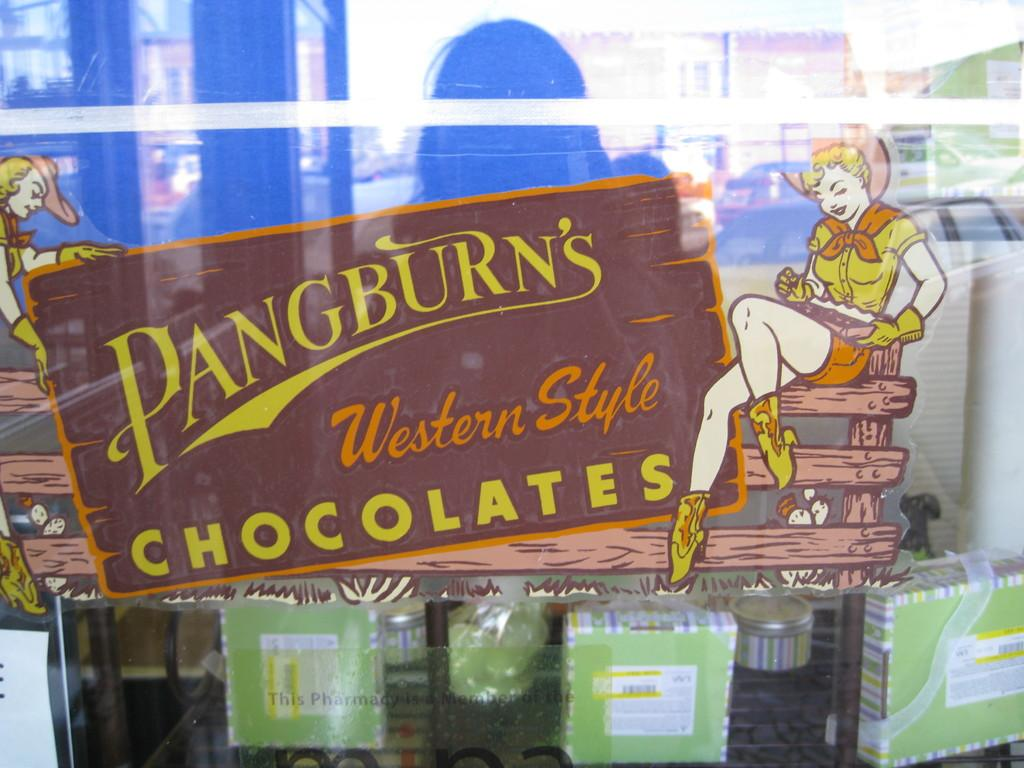What type of wall is visible in the image? There is a glass wall in the image. What is depicted on the glass wall? The glass wall has a cartoon image of women and names painted on it. What can be seen in the background of the image? There are boxes, buildings, and a person in the background of the image. How does the goldfish contribute to the image? There is no goldfish present in the image. 